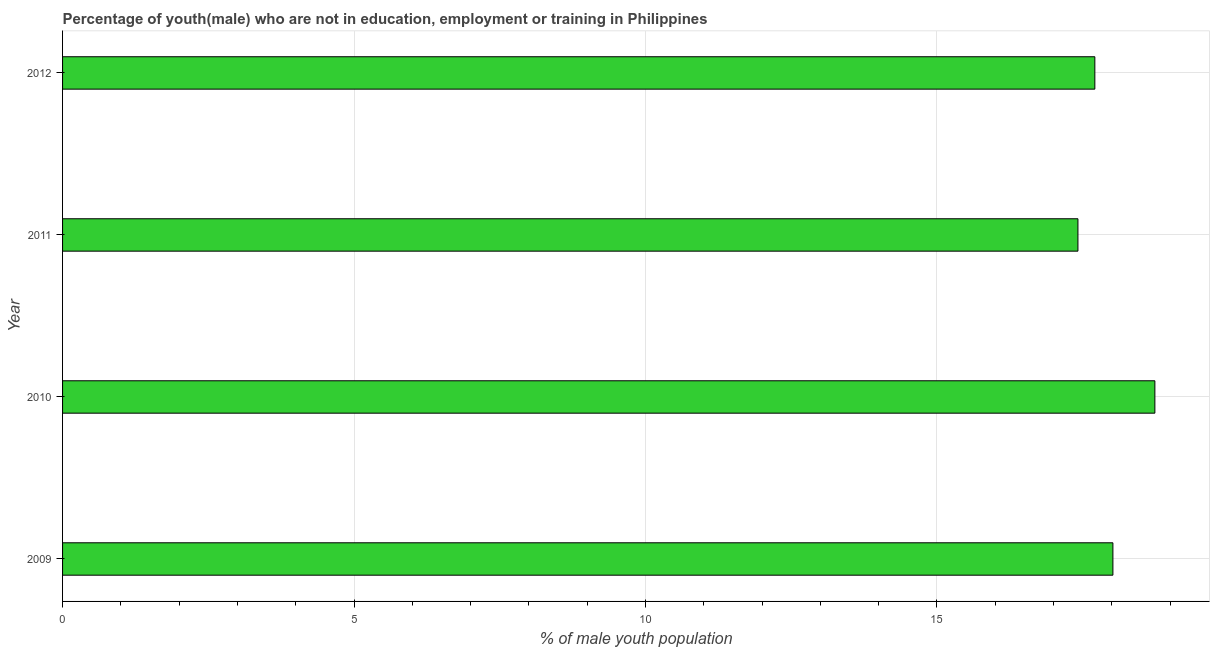Does the graph contain any zero values?
Your answer should be very brief. No. What is the title of the graph?
Provide a succinct answer. Percentage of youth(male) who are not in education, employment or training in Philippines. What is the label or title of the X-axis?
Offer a very short reply. % of male youth population. What is the label or title of the Y-axis?
Your answer should be compact. Year. What is the unemployed male youth population in 2010?
Your response must be concise. 18.74. Across all years, what is the maximum unemployed male youth population?
Your answer should be very brief. 18.74. Across all years, what is the minimum unemployed male youth population?
Keep it short and to the point. 17.42. In which year was the unemployed male youth population maximum?
Give a very brief answer. 2010. What is the sum of the unemployed male youth population?
Offer a terse response. 71.89. What is the difference between the unemployed male youth population in 2011 and 2012?
Provide a short and direct response. -0.29. What is the average unemployed male youth population per year?
Keep it short and to the point. 17.97. What is the median unemployed male youth population?
Provide a succinct answer. 17.86. In how many years, is the unemployed male youth population greater than 14 %?
Offer a very short reply. 4. Do a majority of the years between 2011 and 2012 (inclusive) have unemployed male youth population greater than 17 %?
Make the answer very short. Yes. Is the unemployed male youth population in 2011 less than that in 2012?
Offer a terse response. Yes. What is the difference between the highest and the second highest unemployed male youth population?
Give a very brief answer. 0.72. What is the difference between the highest and the lowest unemployed male youth population?
Ensure brevity in your answer.  1.32. In how many years, is the unemployed male youth population greater than the average unemployed male youth population taken over all years?
Give a very brief answer. 2. Are all the bars in the graph horizontal?
Provide a short and direct response. Yes. What is the % of male youth population of 2009?
Provide a succinct answer. 18.02. What is the % of male youth population in 2010?
Provide a short and direct response. 18.74. What is the % of male youth population in 2011?
Your response must be concise. 17.42. What is the % of male youth population in 2012?
Keep it short and to the point. 17.71. What is the difference between the % of male youth population in 2009 and 2010?
Your answer should be very brief. -0.72. What is the difference between the % of male youth population in 2009 and 2012?
Your response must be concise. 0.31. What is the difference between the % of male youth population in 2010 and 2011?
Offer a very short reply. 1.32. What is the difference between the % of male youth population in 2010 and 2012?
Give a very brief answer. 1.03. What is the difference between the % of male youth population in 2011 and 2012?
Keep it short and to the point. -0.29. What is the ratio of the % of male youth population in 2009 to that in 2011?
Your answer should be compact. 1.03. What is the ratio of the % of male youth population in 2009 to that in 2012?
Your answer should be very brief. 1.02. What is the ratio of the % of male youth population in 2010 to that in 2011?
Your answer should be very brief. 1.08. What is the ratio of the % of male youth population in 2010 to that in 2012?
Your response must be concise. 1.06. 